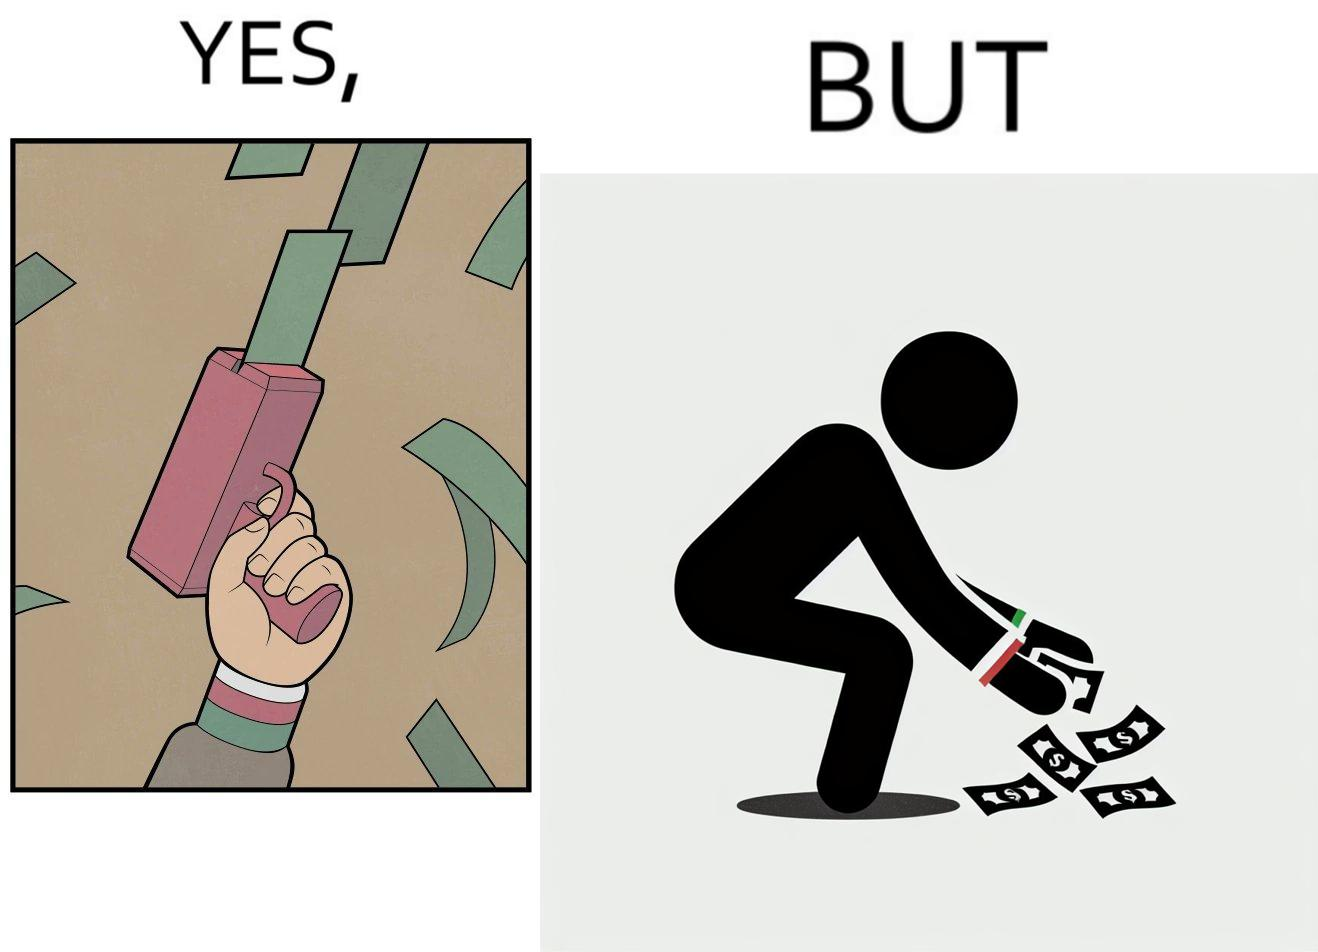Is this a satirical image? Yes, this image is satirical. 